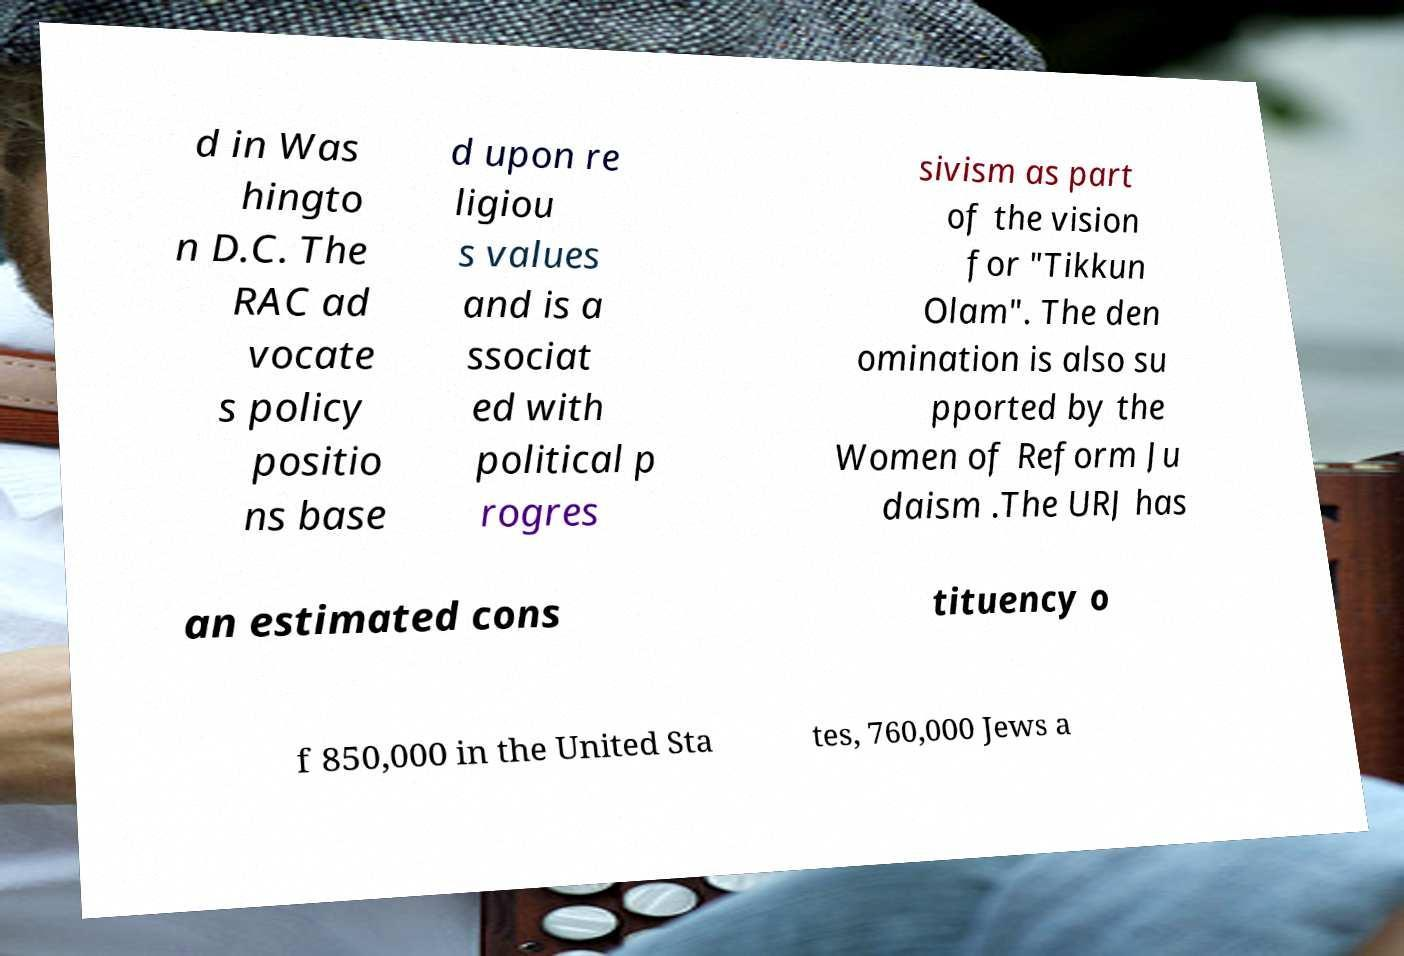Please read and relay the text visible in this image. What does it say? d in Was hingto n D.C. The RAC ad vocate s policy positio ns base d upon re ligiou s values and is a ssociat ed with political p rogres sivism as part of the vision for "Tikkun Olam". The den omination is also su pported by the Women of Reform Ju daism .The URJ has an estimated cons tituency o f 850,000 in the United Sta tes, 760,000 Jews a 